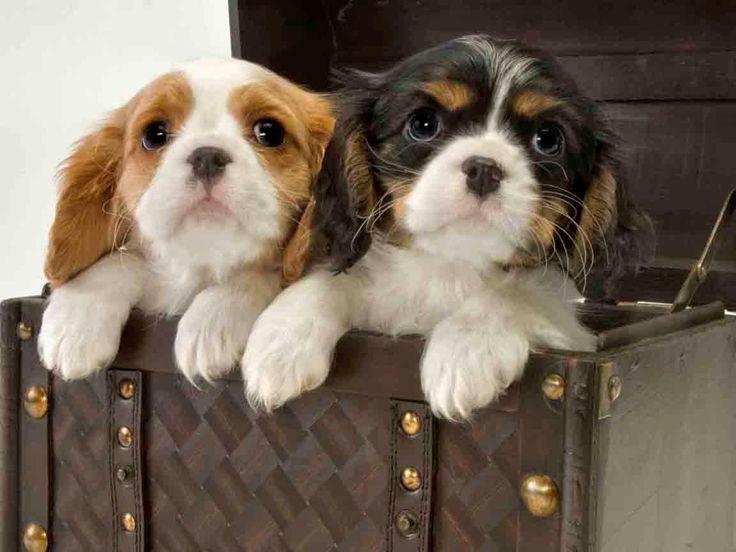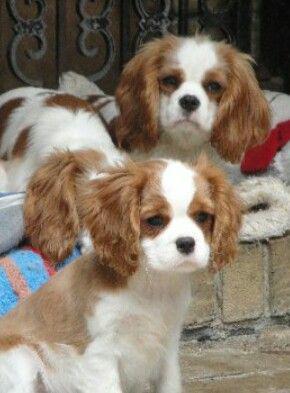The first image is the image on the left, the second image is the image on the right. Assess this claim about the two images: "All images contain only one dog.". Correct or not? Answer yes or no. No. 